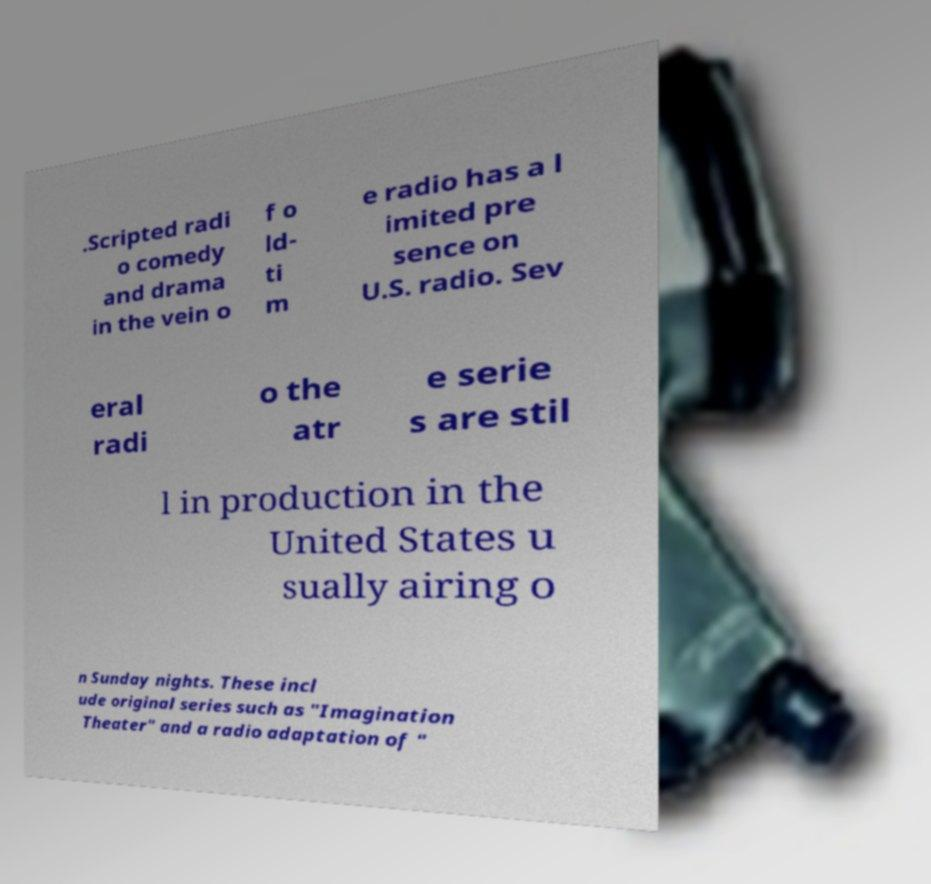Could you extract and type out the text from this image? .Scripted radi o comedy and drama in the vein o f o ld- ti m e radio has a l imited pre sence on U.S. radio. Sev eral radi o the atr e serie s are stil l in production in the United States u sually airing o n Sunday nights. These incl ude original series such as "Imagination Theater" and a radio adaptation of " 